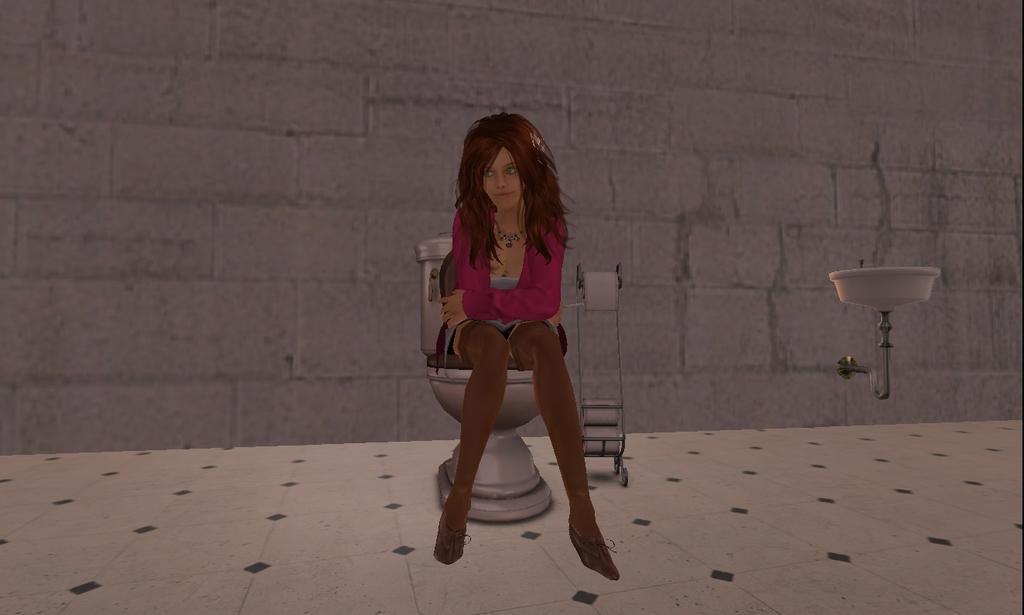In one or two sentences, can you explain what this image depicts? This is an animated image. Here I can see a woman sitting on a toilet. In the background there is a wall. 